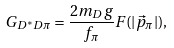Convert formula to latex. <formula><loc_0><loc_0><loc_500><loc_500>G _ { D ^ { * } D \pi } = \frac { 2 m _ { D } g } { f _ { \pi } } F ( | \vec { p } _ { \pi } | ) ,</formula> 